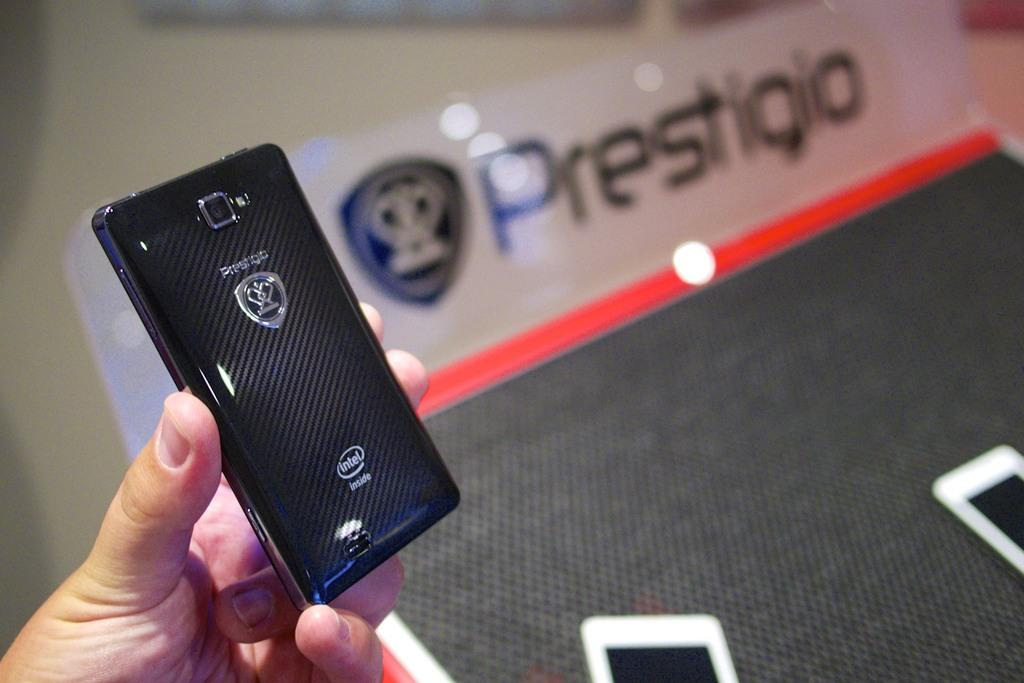<image>
Offer a succinct explanation of the picture presented. a phone that has prestigio written on it 